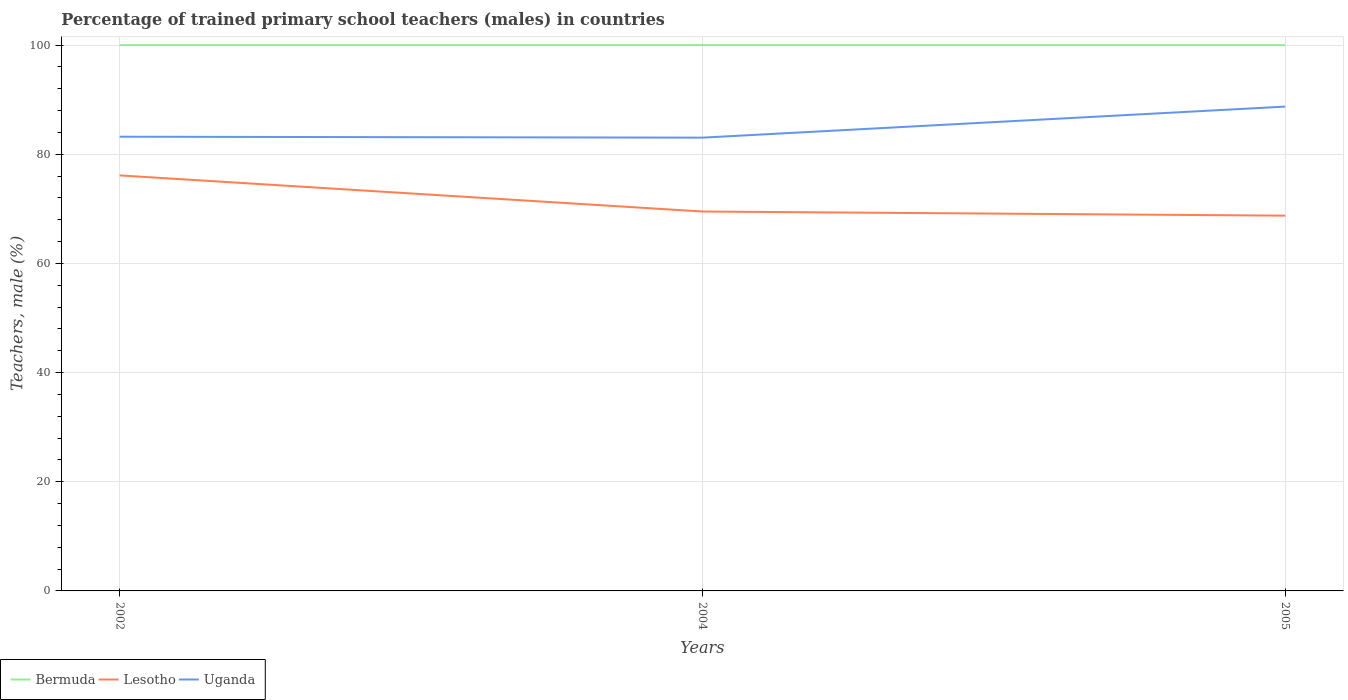Is the number of lines equal to the number of legend labels?
Give a very brief answer. Yes. Across all years, what is the maximum percentage of trained primary school teachers (males) in Uganda?
Ensure brevity in your answer.  83.05. In which year was the percentage of trained primary school teachers (males) in Bermuda maximum?
Make the answer very short. 2002. What is the total percentage of trained primary school teachers (males) in Lesotho in the graph?
Your response must be concise. 7.38. Is the percentage of trained primary school teachers (males) in Bermuda strictly greater than the percentage of trained primary school teachers (males) in Lesotho over the years?
Keep it short and to the point. No. How many lines are there?
Your response must be concise. 3. How many years are there in the graph?
Make the answer very short. 3. What is the difference between two consecutive major ticks on the Y-axis?
Keep it short and to the point. 20. How many legend labels are there?
Make the answer very short. 3. What is the title of the graph?
Keep it short and to the point. Percentage of trained primary school teachers (males) in countries. What is the label or title of the X-axis?
Offer a terse response. Years. What is the label or title of the Y-axis?
Make the answer very short. Teachers, male (%). What is the Teachers, male (%) of Bermuda in 2002?
Provide a short and direct response. 100. What is the Teachers, male (%) of Lesotho in 2002?
Keep it short and to the point. 76.13. What is the Teachers, male (%) in Uganda in 2002?
Ensure brevity in your answer.  83.21. What is the Teachers, male (%) of Bermuda in 2004?
Ensure brevity in your answer.  100. What is the Teachers, male (%) of Lesotho in 2004?
Offer a very short reply. 69.51. What is the Teachers, male (%) of Uganda in 2004?
Provide a succinct answer. 83.05. What is the Teachers, male (%) in Lesotho in 2005?
Provide a short and direct response. 68.75. What is the Teachers, male (%) in Uganda in 2005?
Offer a terse response. 88.73. Across all years, what is the maximum Teachers, male (%) in Bermuda?
Provide a succinct answer. 100. Across all years, what is the maximum Teachers, male (%) in Lesotho?
Provide a succinct answer. 76.13. Across all years, what is the maximum Teachers, male (%) of Uganda?
Provide a succinct answer. 88.73. Across all years, what is the minimum Teachers, male (%) in Bermuda?
Keep it short and to the point. 100. Across all years, what is the minimum Teachers, male (%) of Lesotho?
Ensure brevity in your answer.  68.75. Across all years, what is the minimum Teachers, male (%) of Uganda?
Your answer should be compact. 83.05. What is the total Teachers, male (%) in Bermuda in the graph?
Your answer should be compact. 300. What is the total Teachers, male (%) of Lesotho in the graph?
Your response must be concise. 214.39. What is the total Teachers, male (%) in Uganda in the graph?
Ensure brevity in your answer.  255. What is the difference between the Teachers, male (%) in Lesotho in 2002 and that in 2004?
Your response must be concise. 6.62. What is the difference between the Teachers, male (%) in Uganda in 2002 and that in 2004?
Your answer should be compact. 0.17. What is the difference between the Teachers, male (%) of Lesotho in 2002 and that in 2005?
Your answer should be very brief. 7.38. What is the difference between the Teachers, male (%) in Uganda in 2002 and that in 2005?
Give a very brief answer. -5.52. What is the difference between the Teachers, male (%) of Lesotho in 2004 and that in 2005?
Offer a very short reply. 0.76. What is the difference between the Teachers, male (%) in Uganda in 2004 and that in 2005?
Keep it short and to the point. -5.69. What is the difference between the Teachers, male (%) in Bermuda in 2002 and the Teachers, male (%) in Lesotho in 2004?
Ensure brevity in your answer.  30.49. What is the difference between the Teachers, male (%) of Bermuda in 2002 and the Teachers, male (%) of Uganda in 2004?
Your answer should be very brief. 16.95. What is the difference between the Teachers, male (%) of Lesotho in 2002 and the Teachers, male (%) of Uganda in 2004?
Provide a succinct answer. -6.92. What is the difference between the Teachers, male (%) in Bermuda in 2002 and the Teachers, male (%) in Lesotho in 2005?
Keep it short and to the point. 31.25. What is the difference between the Teachers, male (%) in Bermuda in 2002 and the Teachers, male (%) in Uganda in 2005?
Your answer should be compact. 11.27. What is the difference between the Teachers, male (%) of Lesotho in 2002 and the Teachers, male (%) of Uganda in 2005?
Ensure brevity in your answer.  -12.61. What is the difference between the Teachers, male (%) of Bermuda in 2004 and the Teachers, male (%) of Lesotho in 2005?
Offer a terse response. 31.25. What is the difference between the Teachers, male (%) in Bermuda in 2004 and the Teachers, male (%) in Uganda in 2005?
Offer a terse response. 11.27. What is the difference between the Teachers, male (%) in Lesotho in 2004 and the Teachers, male (%) in Uganda in 2005?
Ensure brevity in your answer.  -19.22. What is the average Teachers, male (%) of Bermuda per year?
Offer a very short reply. 100. What is the average Teachers, male (%) in Lesotho per year?
Offer a terse response. 71.46. What is the average Teachers, male (%) in Uganda per year?
Provide a short and direct response. 85. In the year 2002, what is the difference between the Teachers, male (%) in Bermuda and Teachers, male (%) in Lesotho?
Ensure brevity in your answer.  23.87. In the year 2002, what is the difference between the Teachers, male (%) of Bermuda and Teachers, male (%) of Uganda?
Your response must be concise. 16.79. In the year 2002, what is the difference between the Teachers, male (%) in Lesotho and Teachers, male (%) in Uganda?
Provide a short and direct response. -7.08. In the year 2004, what is the difference between the Teachers, male (%) in Bermuda and Teachers, male (%) in Lesotho?
Ensure brevity in your answer.  30.49. In the year 2004, what is the difference between the Teachers, male (%) in Bermuda and Teachers, male (%) in Uganda?
Offer a terse response. 16.95. In the year 2004, what is the difference between the Teachers, male (%) in Lesotho and Teachers, male (%) in Uganda?
Your answer should be very brief. -13.54. In the year 2005, what is the difference between the Teachers, male (%) of Bermuda and Teachers, male (%) of Lesotho?
Your response must be concise. 31.25. In the year 2005, what is the difference between the Teachers, male (%) in Bermuda and Teachers, male (%) in Uganda?
Offer a very short reply. 11.27. In the year 2005, what is the difference between the Teachers, male (%) in Lesotho and Teachers, male (%) in Uganda?
Ensure brevity in your answer.  -19.98. What is the ratio of the Teachers, male (%) in Lesotho in 2002 to that in 2004?
Your answer should be compact. 1.1. What is the ratio of the Teachers, male (%) in Bermuda in 2002 to that in 2005?
Your answer should be very brief. 1. What is the ratio of the Teachers, male (%) in Lesotho in 2002 to that in 2005?
Provide a succinct answer. 1.11. What is the ratio of the Teachers, male (%) of Uganda in 2002 to that in 2005?
Offer a very short reply. 0.94. What is the ratio of the Teachers, male (%) of Uganda in 2004 to that in 2005?
Ensure brevity in your answer.  0.94. What is the difference between the highest and the second highest Teachers, male (%) in Bermuda?
Ensure brevity in your answer.  0. What is the difference between the highest and the second highest Teachers, male (%) in Lesotho?
Make the answer very short. 6.62. What is the difference between the highest and the second highest Teachers, male (%) of Uganda?
Ensure brevity in your answer.  5.52. What is the difference between the highest and the lowest Teachers, male (%) in Lesotho?
Your answer should be compact. 7.38. What is the difference between the highest and the lowest Teachers, male (%) in Uganda?
Keep it short and to the point. 5.69. 